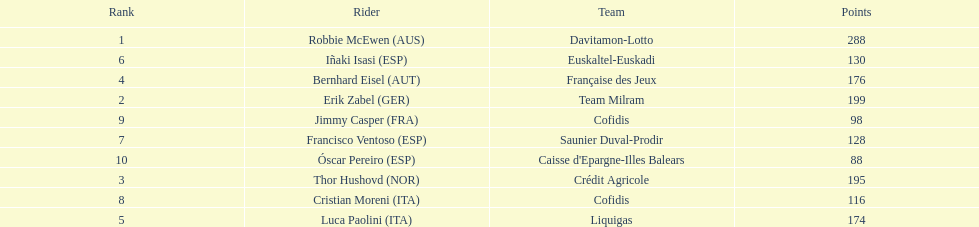How many more points did erik zabel score than franciso ventoso? 71. 